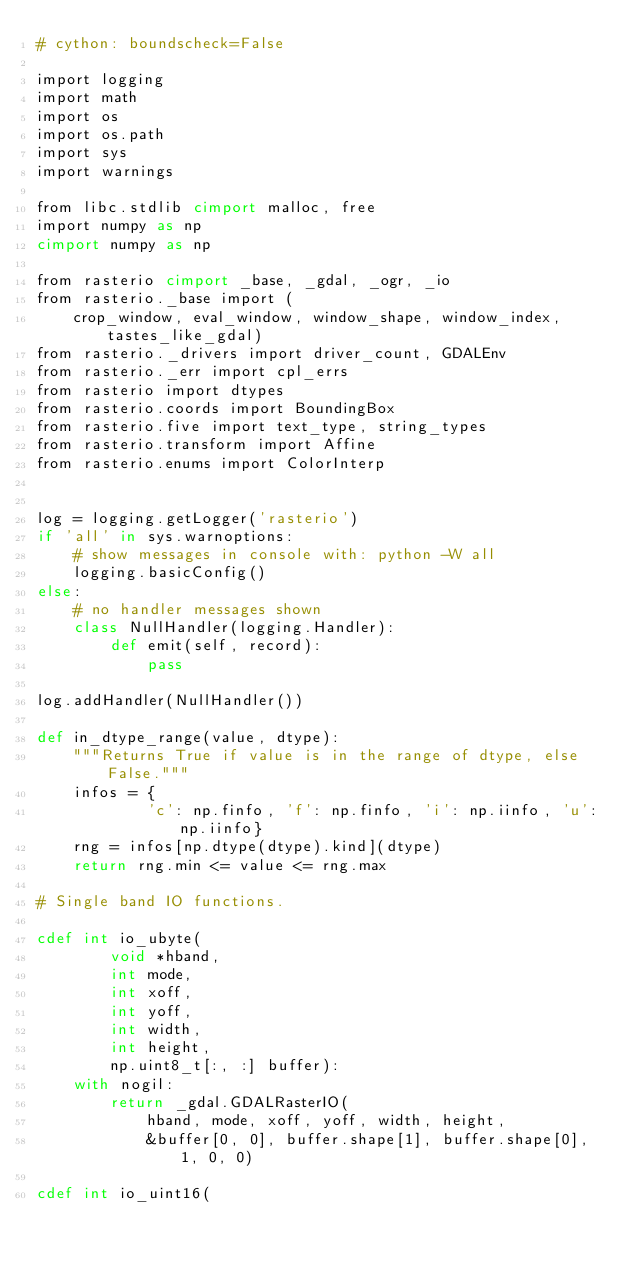<code> <loc_0><loc_0><loc_500><loc_500><_Cython_># cython: boundscheck=False

import logging
import math
import os
import os.path
import sys
import warnings

from libc.stdlib cimport malloc, free
import numpy as np
cimport numpy as np

from rasterio cimport _base, _gdal, _ogr, _io
from rasterio._base import (
    crop_window, eval_window, window_shape, window_index, tastes_like_gdal)
from rasterio._drivers import driver_count, GDALEnv
from rasterio._err import cpl_errs
from rasterio import dtypes
from rasterio.coords import BoundingBox
from rasterio.five import text_type, string_types
from rasterio.transform import Affine
from rasterio.enums import ColorInterp


log = logging.getLogger('rasterio')
if 'all' in sys.warnoptions:
    # show messages in console with: python -W all
    logging.basicConfig()
else:
    # no handler messages shown
    class NullHandler(logging.Handler):
        def emit(self, record):
            pass

log.addHandler(NullHandler())

def in_dtype_range(value, dtype):
    """Returns True if value is in the range of dtype, else False."""
    infos = {
            'c': np.finfo, 'f': np.finfo, 'i': np.iinfo, 'u': np.iinfo}
    rng = infos[np.dtype(dtype).kind](dtype)
    return rng.min <= value <= rng.max

# Single band IO functions.

cdef int io_ubyte(
        void *hband,
        int mode,
        int xoff,
        int yoff,
        int width, 
        int height, 
        np.uint8_t[:, :] buffer):
    with nogil:
        return _gdal.GDALRasterIO(
            hband, mode, xoff, yoff, width, height,
            &buffer[0, 0], buffer.shape[1], buffer.shape[0], 1, 0, 0)

cdef int io_uint16(</code> 